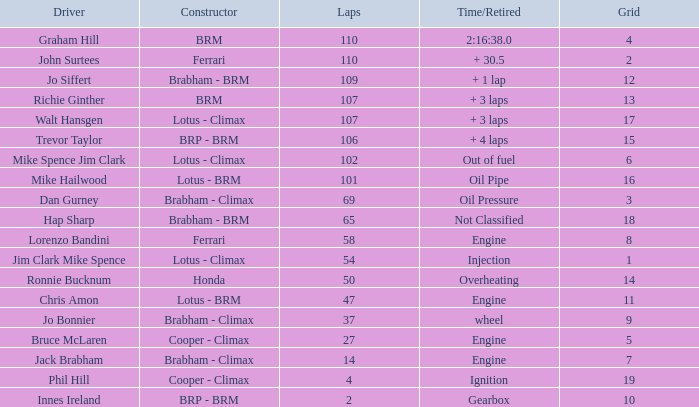What driver has a Time/Retired of 2:16:38.0? Graham Hill. 